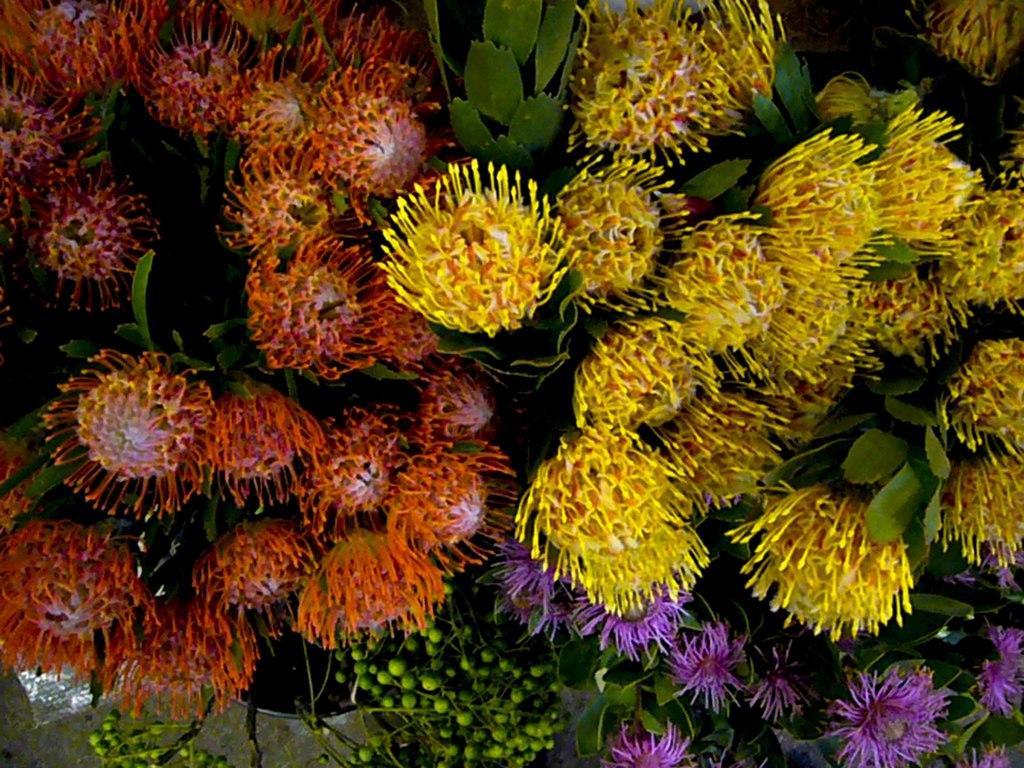Please provide a concise description of this image. Here in this picture we can see aquatic plants present in water. 